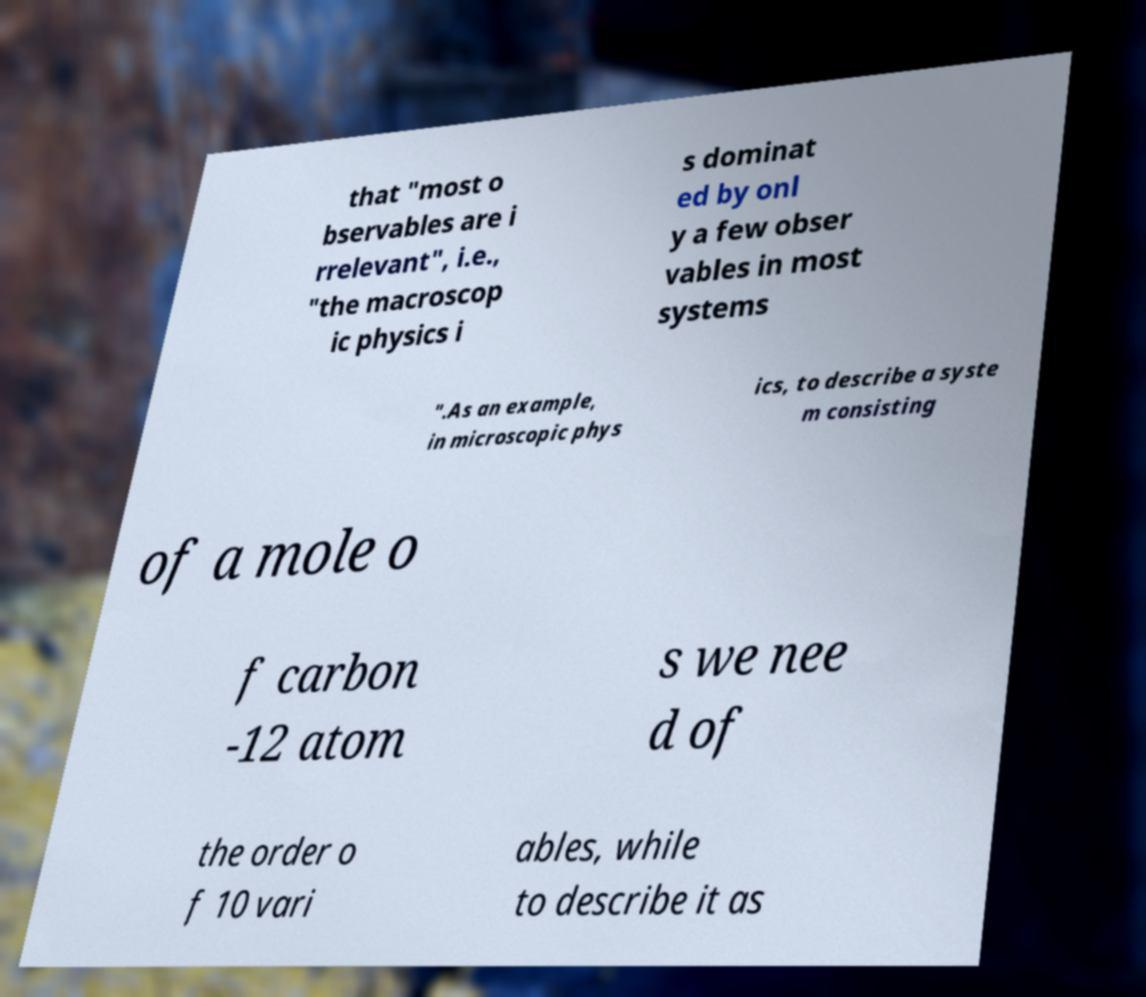For documentation purposes, I need the text within this image transcribed. Could you provide that? that "most o bservables are i rrelevant", i.e., "the macroscop ic physics i s dominat ed by onl y a few obser vables in most systems ".As an example, in microscopic phys ics, to describe a syste m consisting of a mole o f carbon -12 atom s we nee d of the order o f 10 vari ables, while to describe it as 